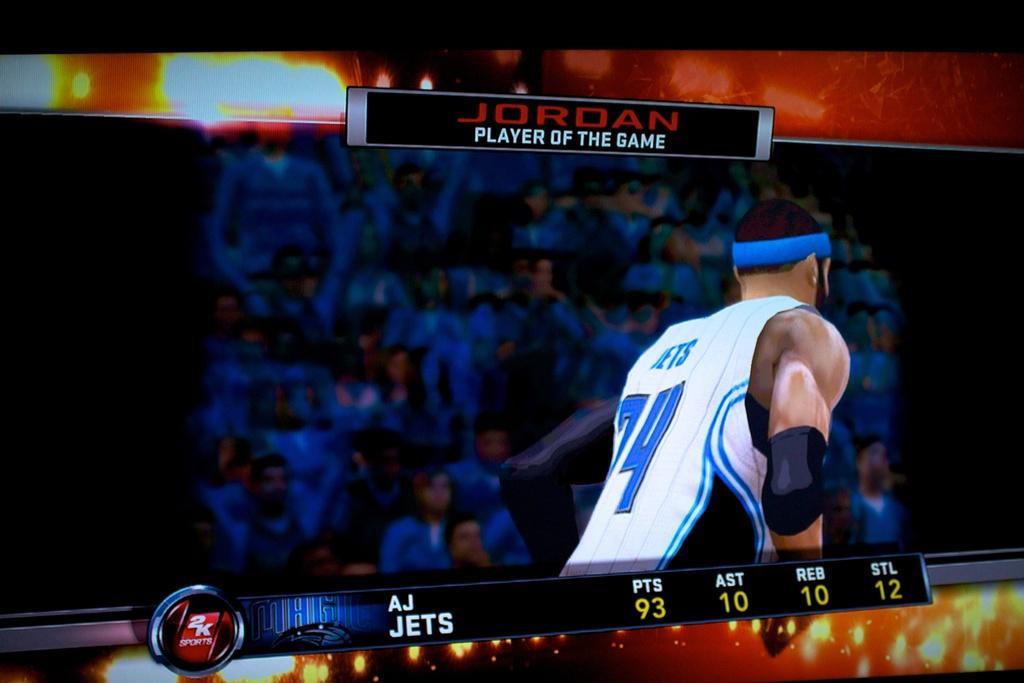How would you summarize this image in a sentence or two? In this picture, we can see an animated person in the white t shirt on the screen and in front of the man there are groups of animated people. 